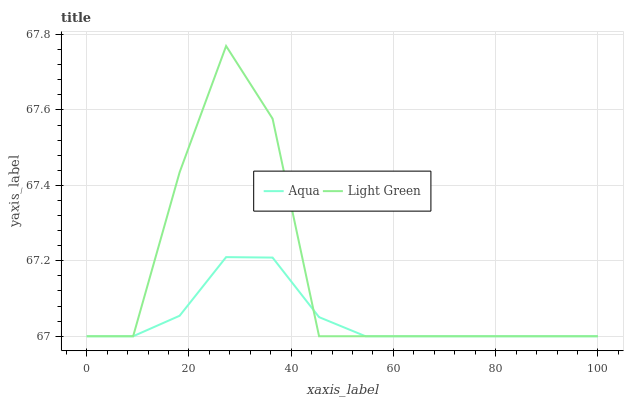Does Aqua have the minimum area under the curve?
Answer yes or no. Yes. Does Light Green have the maximum area under the curve?
Answer yes or no. Yes. Does Light Green have the minimum area under the curve?
Answer yes or no. No. Is Aqua the smoothest?
Answer yes or no. Yes. Is Light Green the roughest?
Answer yes or no. Yes. Is Light Green the smoothest?
Answer yes or no. No. Does Aqua have the lowest value?
Answer yes or no. Yes. Does Light Green have the highest value?
Answer yes or no. Yes. Does Aqua intersect Light Green?
Answer yes or no. Yes. Is Aqua less than Light Green?
Answer yes or no. No. Is Aqua greater than Light Green?
Answer yes or no. No. 